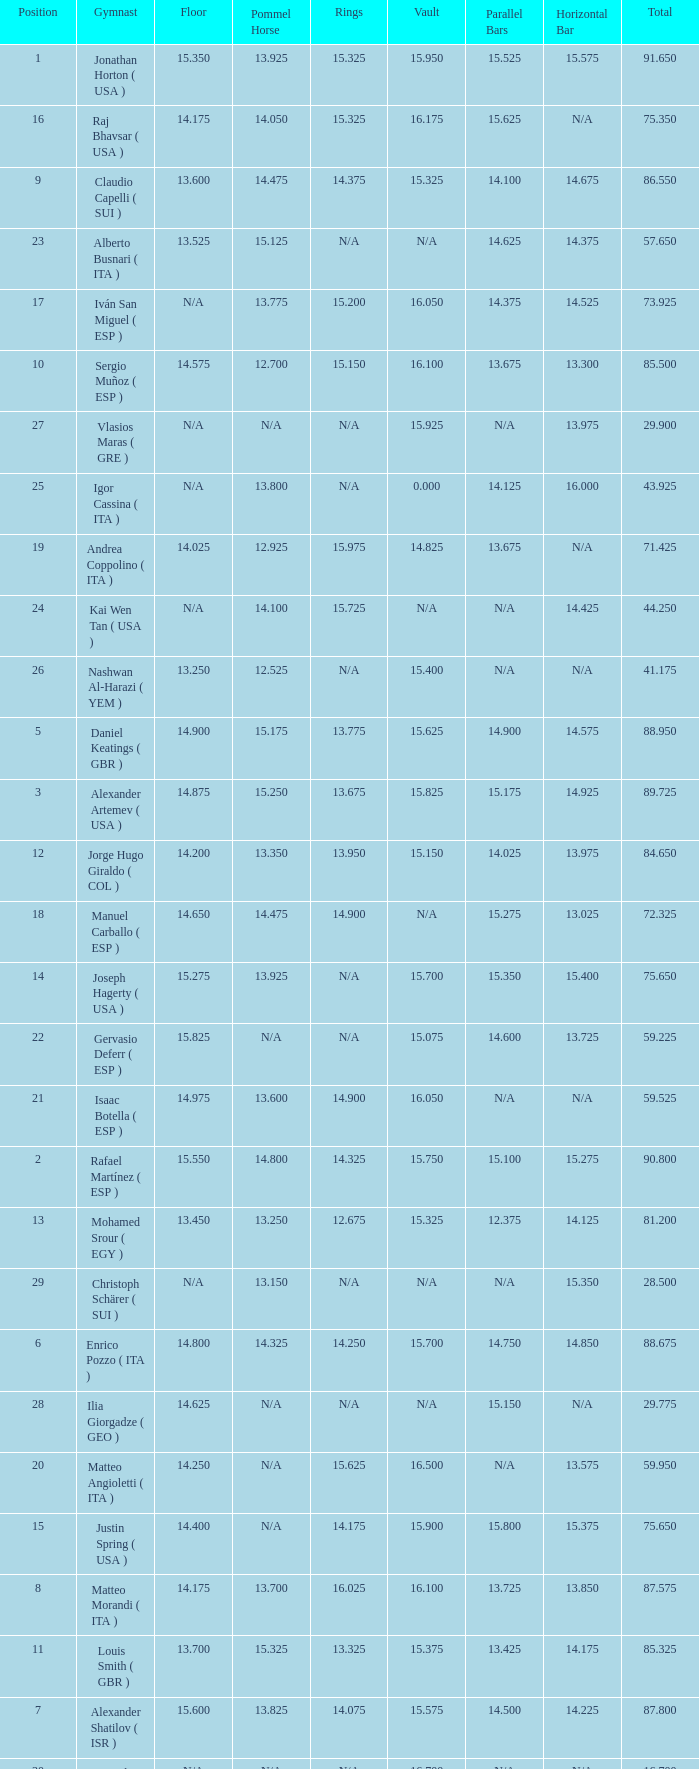If the horizontal bar is n/a and the floor is 14.175, what is the number for the parallel bars? 15.625. 